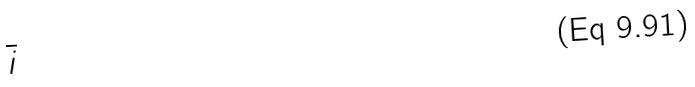<formula> <loc_0><loc_0><loc_500><loc_500>\overline { i }</formula> 